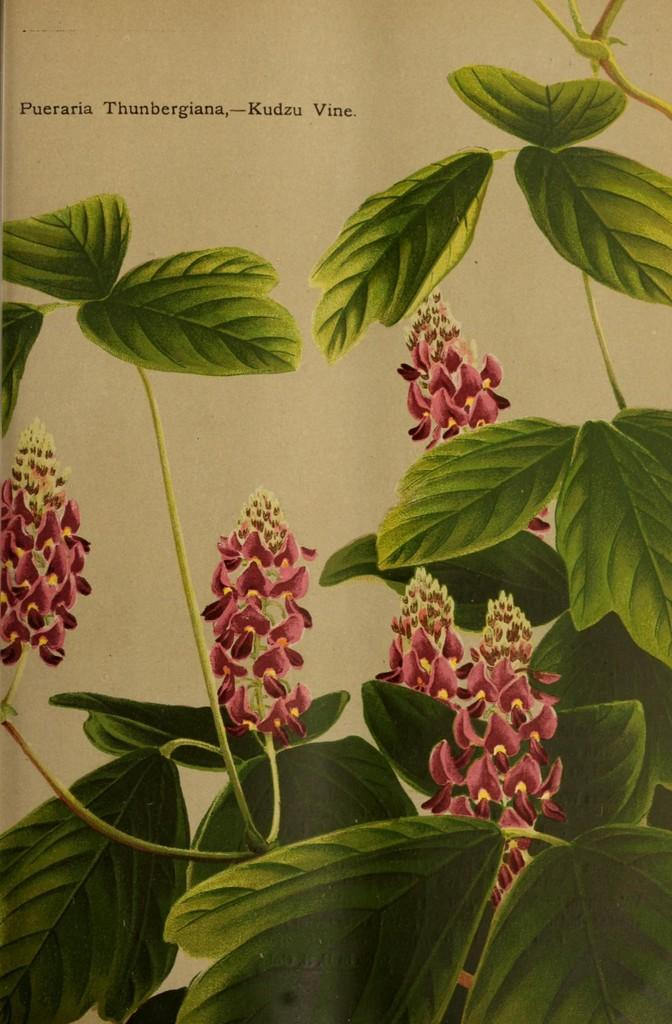What is the main subject of the image? The main subject of the image is a page. What types of natural elements are depicted on the page? The page contains flowers and leaves. Is there any text present on the page? Yes, there is text on the page. Where is the mailbox located on the page? There is no mailbox present on the page; it only contains flowers, leaves, and text. What type of quiver is shown holding the flowers on the page? There is no quiver present on the page; it only contains flowers, leaves, and text. 